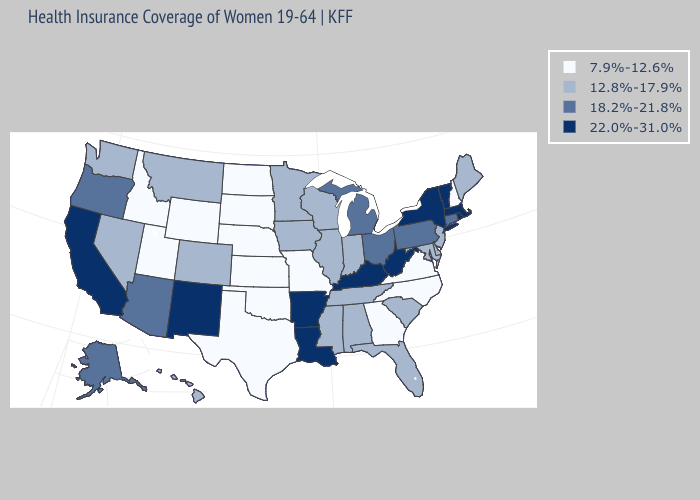What is the value of Wyoming?
Quick response, please. 7.9%-12.6%. Name the states that have a value in the range 22.0%-31.0%?
Write a very short answer. Arkansas, California, Kentucky, Louisiana, Massachusetts, New Mexico, New York, Rhode Island, Vermont, West Virginia. What is the value of Georgia?
Be succinct. 7.9%-12.6%. What is the value of Texas?
Short answer required. 7.9%-12.6%. What is the highest value in states that border Oregon?
Keep it brief. 22.0%-31.0%. Name the states that have a value in the range 12.8%-17.9%?
Give a very brief answer. Alabama, Colorado, Delaware, Florida, Hawaii, Illinois, Indiana, Iowa, Maine, Maryland, Minnesota, Mississippi, Montana, Nevada, New Jersey, South Carolina, Tennessee, Washington, Wisconsin. Name the states that have a value in the range 7.9%-12.6%?
Give a very brief answer. Georgia, Idaho, Kansas, Missouri, Nebraska, New Hampshire, North Carolina, North Dakota, Oklahoma, South Dakota, Texas, Utah, Virginia, Wyoming. Among the states that border Nevada , does Oregon have the highest value?
Short answer required. No. Which states hav the highest value in the West?
Give a very brief answer. California, New Mexico. What is the value of Utah?
Give a very brief answer. 7.9%-12.6%. What is the highest value in the USA?
Be succinct. 22.0%-31.0%. Name the states that have a value in the range 22.0%-31.0%?
Give a very brief answer. Arkansas, California, Kentucky, Louisiana, Massachusetts, New Mexico, New York, Rhode Island, Vermont, West Virginia. Name the states that have a value in the range 22.0%-31.0%?
Write a very short answer. Arkansas, California, Kentucky, Louisiana, Massachusetts, New Mexico, New York, Rhode Island, Vermont, West Virginia. What is the lowest value in the USA?
Give a very brief answer. 7.9%-12.6%. What is the lowest value in states that border Florida?
Be succinct. 7.9%-12.6%. 